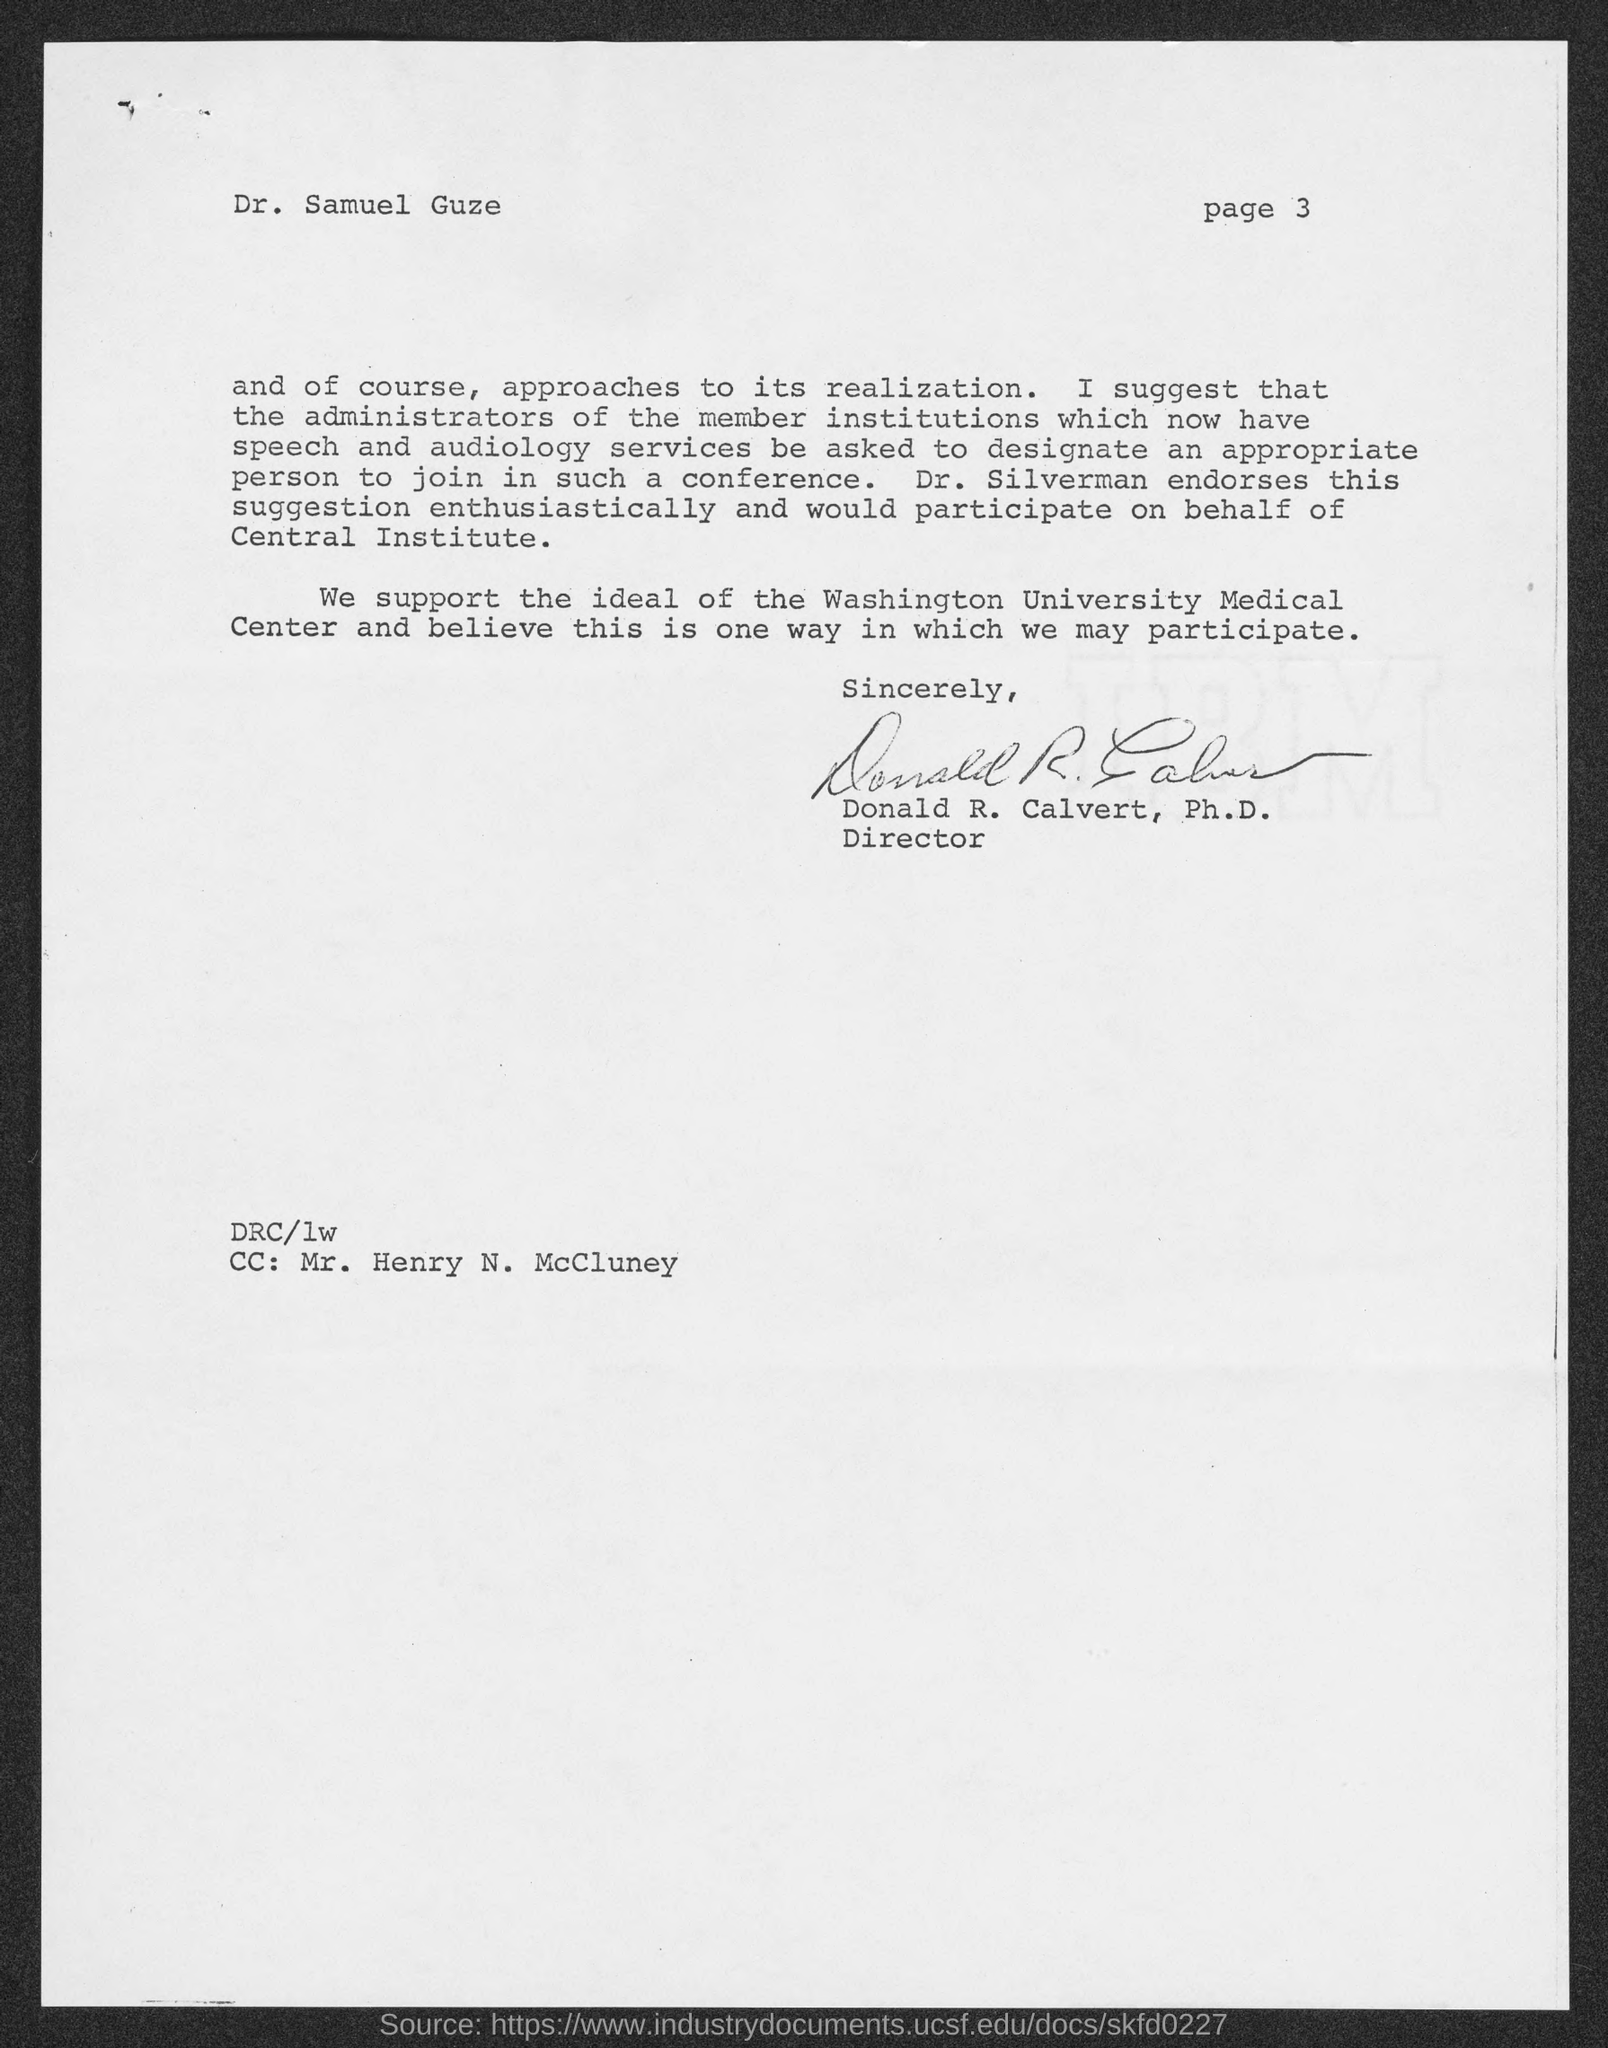Specify some key components in this picture. The memorandum is addressed to Dr. Samuel Guze. Donald R. Calvert, Ph.D., is the Director. The person referred to as the "CC" address is Mr. Henry N. McCluney. The Page number is 3, as declared. 